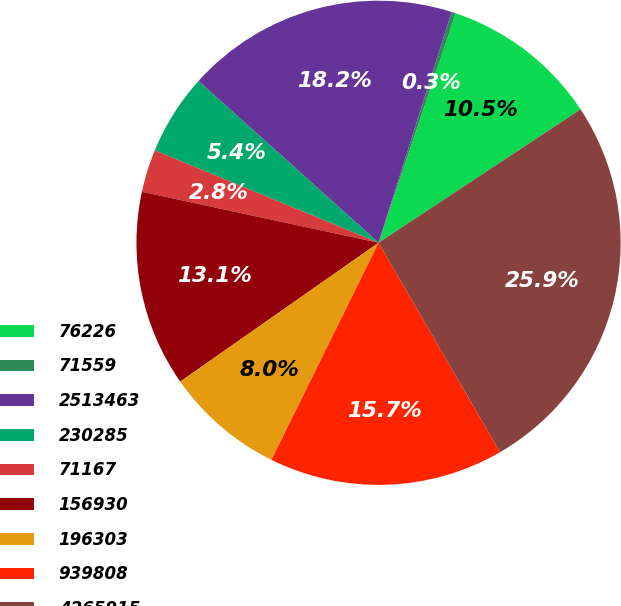Convert chart. <chart><loc_0><loc_0><loc_500><loc_500><pie_chart><fcel>76226<fcel>71559<fcel>2513463<fcel>230285<fcel>71167<fcel>156930<fcel>196303<fcel>939808<fcel>4265915<nl><fcel>10.54%<fcel>0.29%<fcel>18.23%<fcel>5.42%<fcel>2.85%<fcel>13.1%<fcel>7.98%<fcel>15.67%<fcel>25.92%<nl></chart> 